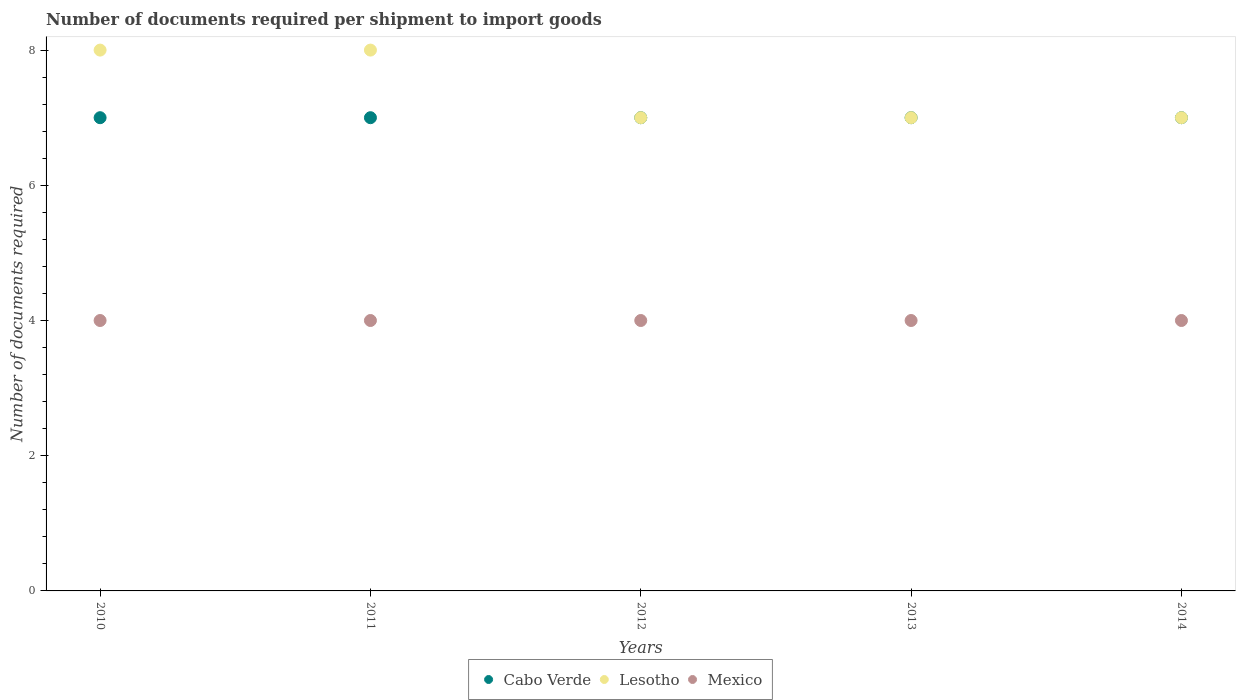Is the number of dotlines equal to the number of legend labels?
Your response must be concise. Yes. What is the number of documents required per shipment to import goods in Mexico in 2014?
Your response must be concise. 4. Across all years, what is the maximum number of documents required per shipment to import goods in Mexico?
Ensure brevity in your answer.  4. Across all years, what is the minimum number of documents required per shipment to import goods in Lesotho?
Provide a short and direct response. 7. In which year was the number of documents required per shipment to import goods in Cabo Verde maximum?
Ensure brevity in your answer.  2010. In which year was the number of documents required per shipment to import goods in Lesotho minimum?
Ensure brevity in your answer.  2012. What is the total number of documents required per shipment to import goods in Cabo Verde in the graph?
Your response must be concise. 35. What is the difference between the number of documents required per shipment to import goods in Mexico in 2010 and that in 2011?
Offer a terse response. 0. What is the difference between the number of documents required per shipment to import goods in Mexico in 2013 and the number of documents required per shipment to import goods in Cabo Verde in 2014?
Offer a very short reply. -3. In the year 2010, what is the difference between the number of documents required per shipment to import goods in Lesotho and number of documents required per shipment to import goods in Mexico?
Your answer should be compact. 4. In how many years, is the number of documents required per shipment to import goods in Lesotho greater than 6.8?
Your answer should be compact. 5. What is the difference between the highest and the second highest number of documents required per shipment to import goods in Mexico?
Provide a short and direct response. 0. What is the difference between the highest and the lowest number of documents required per shipment to import goods in Lesotho?
Ensure brevity in your answer.  1. In how many years, is the number of documents required per shipment to import goods in Cabo Verde greater than the average number of documents required per shipment to import goods in Cabo Verde taken over all years?
Offer a very short reply. 0. Is the sum of the number of documents required per shipment to import goods in Mexico in 2010 and 2012 greater than the maximum number of documents required per shipment to import goods in Cabo Verde across all years?
Make the answer very short. Yes. Is it the case that in every year, the sum of the number of documents required per shipment to import goods in Cabo Verde and number of documents required per shipment to import goods in Mexico  is greater than the number of documents required per shipment to import goods in Lesotho?
Provide a succinct answer. Yes. Is the number of documents required per shipment to import goods in Cabo Verde strictly greater than the number of documents required per shipment to import goods in Mexico over the years?
Offer a terse response. Yes. Is the number of documents required per shipment to import goods in Mexico strictly less than the number of documents required per shipment to import goods in Lesotho over the years?
Provide a succinct answer. Yes. How many dotlines are there?
Your answer should be very brief. 3. What is the difference between two consecutive major ticks on the Y-axis?
Your answer should be very brief. 2. Are the values on the major ticks of Y-axis written in scientific E-notation?
Provide a succinct answer. No. Does the graph contain any zero values?
Ensure brevity in your answer.  No. Does the graph contain grids?
Offer a very short reply. No. How are the legend labels stacked?
Make the answer very short. Horizontal. What is the title of the graph?
Provide a succinct answer. Number of documents required per shipment to import goods. Does "Congo (Democratic)" appear as one of the legend labels in the graph?
Ensure brevity in your answer.  No. What is the label or title of the X-axis?
Your answer should be very brief. Years. What is the label or title of the Y-axis?
Provide a succinct answer. Number of documents required. What is the Number of documents required of Cabo Verde in 2010?
Offer a very short reply. 7. What is the Number of documents required in Lesotho in 2010?
Your answer should be compact. 8. What is the Number of documents required of Mexico in 2010?
Offer a very short reply. 4. What is the Number of documents required in Mexico in 2011?
Provide a succinct answer. 4. What is the Number of documents required of Lesotho in 2012?
Your answer should be very brief. 7. What is the Number of documents required in Mexico in 2012?
Offer a terse response. 4. What is the Number of documents required in Cabo Verde in 2013?
Your answer should be compact. 7. Across all years, what is the maximum Number of documents required in Mexico?
Keep it short and to the point. 4. Across all years, what is the minimum Number of documents required of Cabo Verde?
Your answer should be very brief. 7. Across all years, what is the minimum Number of documents required in Mexico?
Your response must be concise. 4. What is the total Number of documents required of Cabo Verde in the graph?
Your answer should be very brief. 35. What is the difference between the Number of documents required in Mexico in 2010 and that in 2011?
Ensure brevity in your answer.  0. What is the difference between the Number of documents required in Cabo Verde in 2010 and that in 2012?
Provide a short and direct response. 0. What is the difference between the Number of documents required in Lesotho in 2010 and that in 2012?
Ensure brevity in your answer.  1. What is the difference between the Number of documents required of Mexico in 2010 and that in 2013?
Your answer should be compact. 0. What is the difference between the Number of documents required in Cabo Verde in 2010 and that in 2014?
Provide a short and direct response. 0. What is the difference between the Number of documents required in Cabo Verde in 2011 and that in 2012?
Your response must be concise. 0. What is the difference between the Number of documents required in Lesotho in 2011 and that in 2012?
Provide a succinct answer. 1. What is the difference between the Number of documents required of Lesotho in 2011 and that in 2013?
Your answer should be compact. 1. What is the difference between the Number of documents required of Mexico in 2011 and that in 2013?
Make the answer very short. 0. What is the difference between the Number of documents required of Cabo Verde in 2011 and that in 2014?
Make the answer very short. 0. What is the difference between the Number of documents required of Lesotho in 2011 and that in 2014?
Offer a terse response. 1. What is the difference between the Number of documents required of Cabo Verde in 2012 and that in 2014?
Your answer should be compact. 0. What is the difference between the Number of documents required in Cabo Verde in 2013 and that in 2014?
Make the answer very short. 0. What is the difference between the Number of documents required of Mexico in 2013 and that in 2014?
Give a very brief answer. 0. What is the difference between the Number of documents required of Cabo Verde in 2010 and the Number of documents required of Mexico in 2011?
Your response must be concise. 3. What is the difference between the Number of documents required in Lesotho in 2010 and the Number of documents required in Mexico in 2011?
Keep it short and to the point. 4. What is the difference between the Number of documents required in Lesotho in 2010 and the Number of documents required in Mexico in 2012?
Offer a very short reply. 4. What is the difference between the Number of documents required in Cabo Verde in 2010 and the Number of documents required in Mexico in 2013?
Make the answer very short. 3. What is the difference between the Number of documents required in Cabo Verde in 2010 and the Number of documents required in Lesotho in 2014?
Offer a terse response. 0. What is the difference between the Number of documents required in Cabo Verde in 2011 and the Number of documents required in Lesotho in 2012?
Your answer should be compact. 0. What is the difference between the Number of documents required in Lesotho in 2011 and the Number of documents required in Mexico in 2012?
Your answer should be very brief. 4. What is the difference between the Number of documents required in Cabo Verde in 2011 and the Number of documents required in Lesotho in 2013?
Your answer should be very brief. 0. What is the difference between the Number of documents required in Lesotho in 2011 and the Number of documents required in Mexico in 2014?
Provide a short and direct response. 4. What is the difference between the Number of documents required of Lesotho in 2012 and the Number of documents required of Mexico in 2013?
Your answer should be very brief. 3. What is the difference between the Number of documents required of Cabo Verde in 2012 and the Number of documents required of Lesotho in 2014?
Provide a short and direct response. 0. What is the average Number of documents required in Cabo Verde per year?
Offer a very short reply. 7. In the year 2010, what is the difference between the Number of documents required of Cabo Verde and Number of documents required of Mexico?
Your answer should be compact. 3. In the year 2011, what is the difference between the Number of documents required of Lesotho and Number of documents required of Mexico?
Offer a terse response. 4. In the year 2012, what is the difference between the Number of documents required in Cabo Verde and Number of documents required in Lesotho?
Your response must be concise. 0. In the year 2013, what is the difference between the Number of documents required in Cabo Verde and Number of documents required in Lesotho?
Your response must be concise. 0. In the year 2013, what is the difference between the Number of documents required in Cabo Verde and Number of documents required in Mexico?
Give a very brief answer. 3. In the year 2013, what is the difference between the Number of documents required of Lesotho and Number of documents required of Mexico?
Keep it short and to the point. 3. In the year 2014, what is the difference between the Number of documents required of Cabo Verde and Number of documents required of Lesotho?
Provide a succinct answer. 0. In the year 2014, what is the difference between the Number of documents required in Cabo Verde and Number of documents required in Mexico?
Offer a terse response. 3. In the year 2014, what is the difference between the Number of documents required of Lesotho and Number of documents required of Mexico?
Provide a succinct answer. 3. What is the ratio of the Number of documents required of Mexico in 2010 to that in 2011?
Provide a succinct answer. 1. What is the ratio of the Number of documents required of Cabo Verde in 2010 to that in 2012?
Your response must be concise. 1. What is the ratio of the Number of documents required of Cabo Verde in 2010 to that in 2013?
Offer a terse response. 1. What is the ratio of the Number of documents required in Cabo Verde in 2011 to that in 2012?
Ensure brevity in your answer.  1. What is the ratio of the Number of documents required in Cabo Verde in 2011 to that in 2013?
Provide a succinct answer. 1. What is the ratio of the Number of documents required of Mexico in 2011 to that in 2014?
Keep it short and to the point. 1. What is the ratio of the Number of documents required of Lesotho in 2012 to that in 2013?
Provide a succinct answer. 1. What is the ratio of the Number of documents required in Mexico in 2012 to that in 2013?
Provide a succinct answer. 1. What is the ratio of the Number of documents required in Cabo Verde in 2012 to that in 2014?
Your answer should be compact. 1. What is the ratio of the Number of documents required in Mexico in 2012 to that in 2014?
Offer a terse response. 1. What is the ratio of the Number of documents required of Cabo Verde in 2013 to that in 2014?
Keep it short and to the point. 1. What is the ratio of the Number of documents required in Mexico in 2013 to that in 2014?
Your answer should be very brief. 1. What is the difference between the highest and the second highest Number of documents required in Cabo Verde?
Your answer should be very brief. 0. What is the difference between the highest and the second highest Number of documents required in Mexico?
Offer a terse response. 0. 